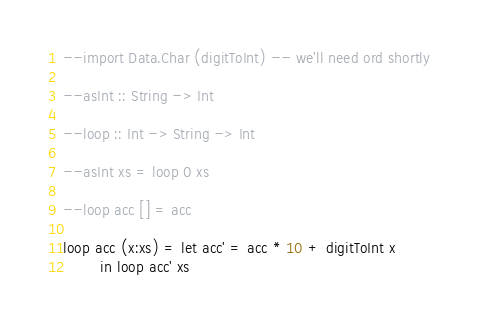<code> <loc_0><loc_0><loc_500><loc_500><_Haskell_>--import Data.Char (digitToInt) -- we'll need ord shortly

--asInt :: String -> Int

--loop :: Int -> String -> Int

--asInt xs = loop 0 xs

--loop acc [] = acc

loop acc (x:xs) = let acc' = acc * 10 + digitToInt x
		in loop acc' xs
</code> 